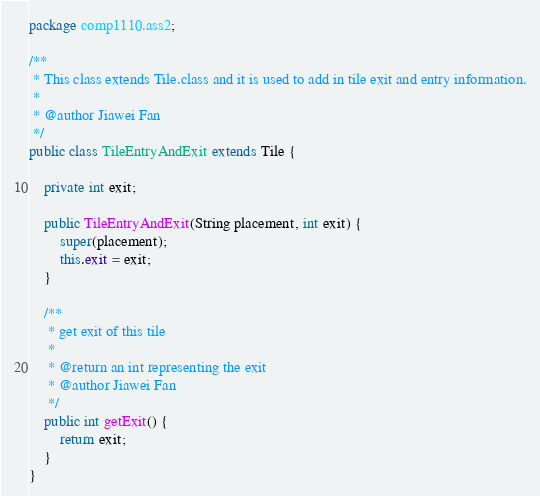Convert code to text. <code><loc_0><loc_0><loc_500><loc_500><_Java_>package comp1110.ass2;

/**
 * This class extends Tile.class and it is used to add in tile exit and entry information.
 *
 * @author Jiawei Fan
 */
public class TileEntryAndExit extends Tile {

    private int exit;

    public TileEntryAndExit(String placement, int exit) {
        super(placement);
        this.exit = exit;
    }

    /**
     * get exit of this tile
     *
     * @return an int representing the exit
     * @author Jiawei Fan
     */
    public int getExit() {
        return exit;
    }
}
</code> 